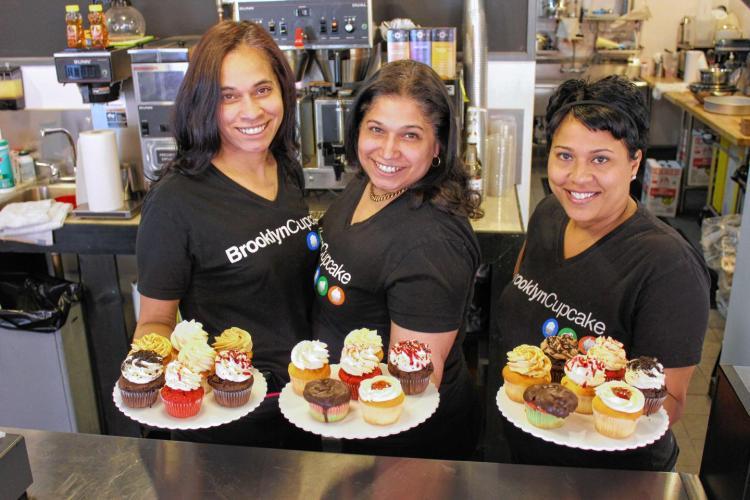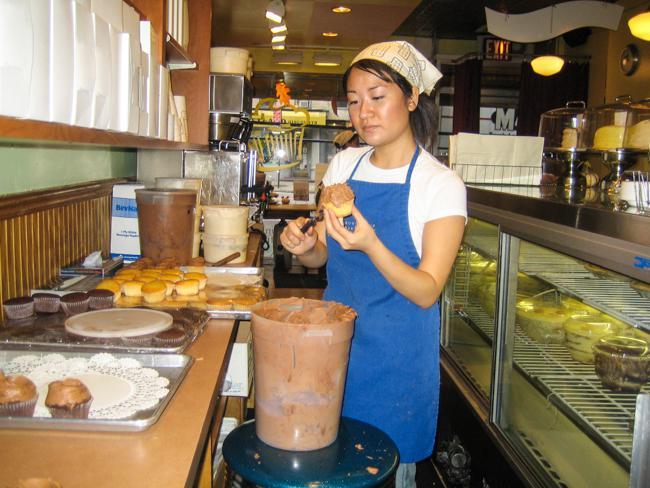The first image is the image on the left, the second image is the image on the right. Analyze the images presented: Is the assertion "a woman behind the counter is wearing a head wrap." valid? Answer yes or no. Yes. The first image is the image on the left, the second image is the image on the right. Given the left and right images, does the statement "An image shows a female worker by a glass case, wearing a scarf on her head." hold true? Answer yes or no. Yes. 